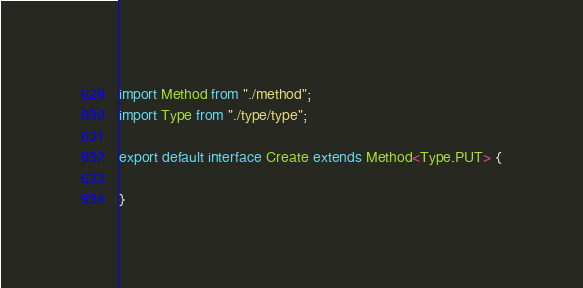Convert code to text. <code><loc_0><loc_0><loc_500><loc_500><_TypeScript_>import Method from "./method";
import Type from "./type/type";

export default interface Create extends Method<Type.PUT> {

}</code> 